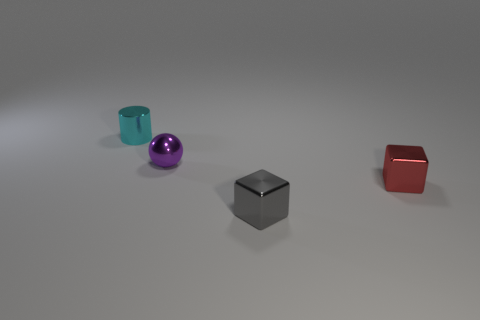Can you describe the lighting setup that might have been used to achieve the shadows in this scene? The soft, diffuse shadows cast by each object, alongside the soft gradient on the ground, imply that the scene is likely lit by a broad, possibly overhead light source. This setup mimics a natural-light condition or uses a large softbox to generate such even illumination and soft-edged shadows. 